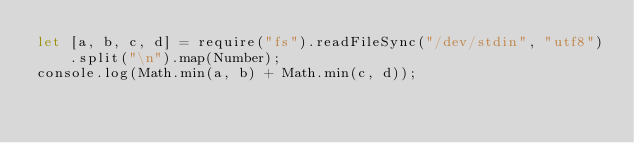<code> <loc_0><loc_0><loc_500><loc_500><_JavaScript_>let [a, b, c, d] = require("fs").readFileSync("/dev/stdin", "utf8").split("\n").map(Number);
console.log(Math.min(a, b) + Math.min(c, d));</code> 